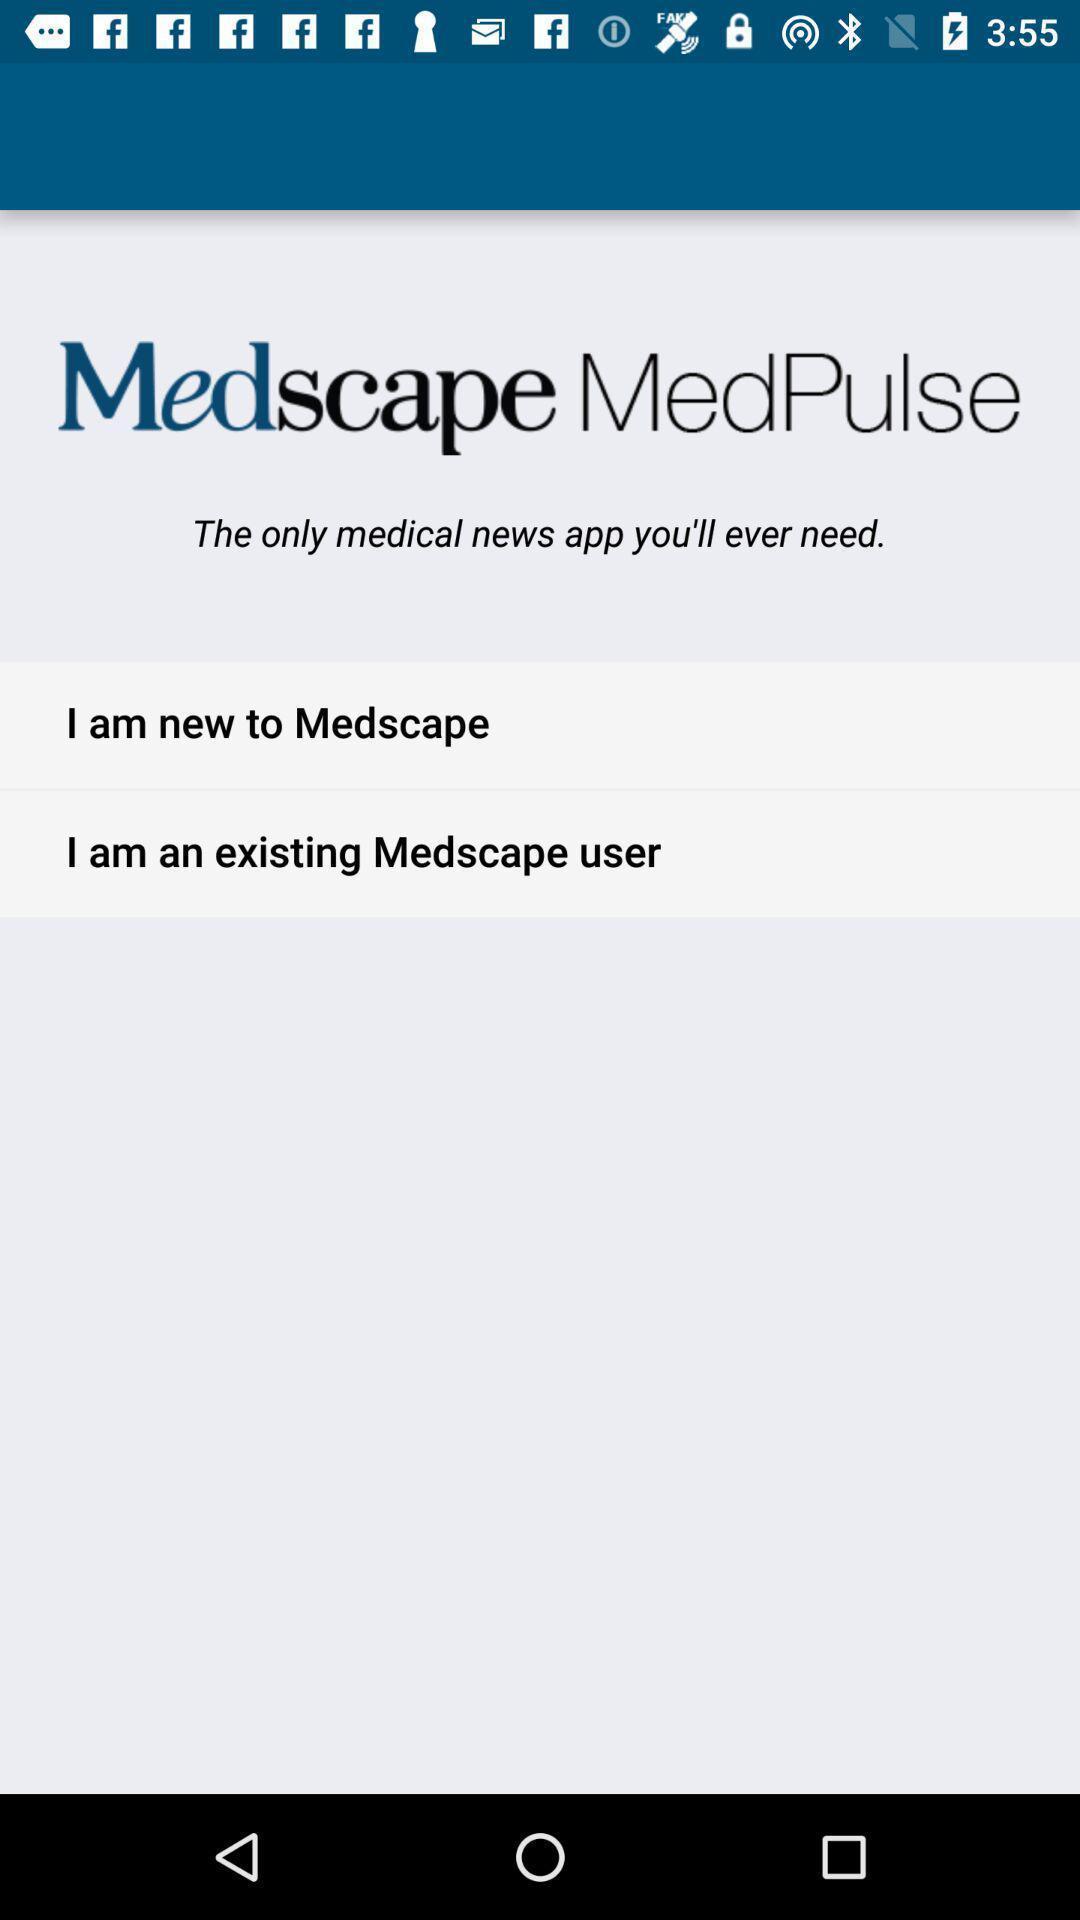Summarize the main components in this picture. Page showing about medical news app. 